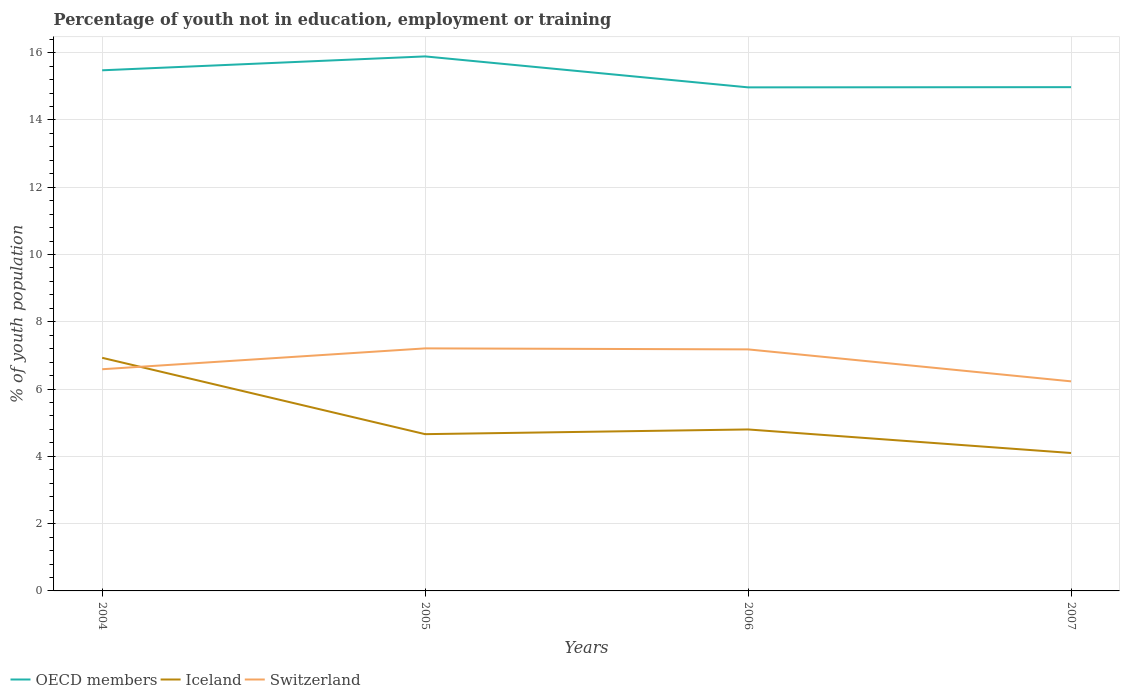How many different coloured lines are there?
Offer a terse response. 3. Does the line corresponding to OECD members intersect with the line corresponding to Iceland?
Ensure brevity in your answer.  No. Is the number of lines equal to the number of legend labels?
Ensure brevity in your answer.  Yes. Across all years, what is the maximum percentage of unemployed youth population in in Iceland?
Provide a succinct answer. 4.1. What is the total percentage of unemployed youth population in in Switzerland in the graph?
Your response must be concise. -0.59. What is the difference between the highest and the second highest percentage of unemployed youth population in in OECD members?
Offer a very short reply. 0.92. What is the difference between the highest and the lowest percentage of unemployed youth population in in Switzerland?
Provide a succinct answer. 2. How many lines are there?
Give a very brief answer. 3. How many years are there in the graph?
Your answer should be compact. 4. Are the values on the major ticks of Y-axis written in scientific E-notation?
Ensure brevity in your answer.  No. Where does the legend appear in the graph?
Ensure brevity in your answer.  Bottom left. What is the title of the graph?
Make the answer very short. Percentage of youth not in education, employment or training. Does "Estonia" appear as one of the legend labels in the graph?
Give a very brief answer. No. What is the label or title of the Y-axis?
Give a very brief answer. % of youth population. What is the % of youth population in OECD members in 2004?
Make the answer very short. 15.48. What is the % of youth population of Iceland in 2004?
Your answer should be compact. 6.93. What is the % of youth population in Switzerland in 2004?
Make the answer very short. 6.59. What is the % of youth population of OECD members in 2005?
Provide a succinct answer. 15.89. What is the % of youth population in Iceland in 2005?
Provide a succinct answer. 4.66. What is the % of youth population in Switzerland in 2005?
Your answer should be very brief. 7.21. What is the % of youth population in OECD members in 2006?
Offer a very short reply. 14.97. What is the % of youth population in Iceland in 2006?
Provide a short and direct response. 4.8. What is the % of youth population in Switzerland in 2006?
Give a very brief answer. 7.18. What is the % of youth population of OECD members in 2007?
Your answer should be compact. 14.98. What is the % of youth population of Iceland in 2007?
Give a very brief answer. 4.1. What is the % of youth population of Switzerland in 2007?
Offer a terse response. 6.23. Across all years, what is the maximum % of youth population of OECD members?
Provide a succinct answer. 15.89. Across all years, what is the maximum % of youth population in Iceland?
Provide a short and direct response. 6.93. Across all years, what is the maximum % of youth population in Switzerland?
Give a very brief answer. 7.21. Across all years, what is the minimum % of youth population of OECD members?
Your answer should be compact. 14.97. Across all years, what is the minimum % of youth population of Iceland?
Ensure brevity in your answer.  4.1. Across all years, what is the minimum % of youth population in Switzerland?
Provide a short and direct response. 6.23. What is the total % of youth population in OECD members in the graph?
Offer a very short reply. 61.31. What is the total % of youth population of Iceland in the graph?
Offer a terse response. 20.49. What is the total % of youth population of Switzerland in the graph?
Offer a terse response. 27.21. What is the difference between the % of youth population in OECD members in 2004 and that in 2005?
Make the answer very short. -0.41. What is the difference between the % of youth population in Iceland in 2004 and that in 2005?
Your response must be concise. 2.27. What is the difference between the % of youth population in Switzerland in 2004 and that in 2005?
Your answer should be compact. -0.62. What is the difference between the % of youth population of OECD members in 2004 and that in 2006?
Make the answer very short. 0.51. What is the difference between the % of youth population in Iceland in 2004 and that in 2006?
Offer a terse response. 2.13. What is the difference between the % of youth population in Switzerland in 2004 and that in 2006?
Provide a short and direct response. -0.59. What is the difference between the % of youth population in OECD members in 2004 and that in 2007?
Provide a succinct answer. 0.5. What is the difference between the % of youth population in Iceland in 2004 and that in 2007?
Your answer should be very brief. 2.83. What is the difference between the % of youth population in Switzerland in 2004 and that in 2007?
Your answer should be compact. 0.36. What is the difference between the % of youth population in OECD members in 2005 and that in 2006?
Provide a succinct answer. 0.92. What is the difference between the % of youth population of Iceland in 2005 and that in 2006?
Make the answer very short. -0.14. What is the difference between the % of youth population in OECD members in 2005 and that in 2007?
Provide a succinct answer. 0.91. What is the difference between the % of youth population of Iceland in 2005 and that in 2007?
Give a very brief answer. 0.56. What is the difference between the % of youth population of OECD members in 2006 and that in 2007?
Your response must be concise. -0.01. What is the difference between the % of youth population in OECD members in 2004 and the % of youth population in Iceland in 2005?
Your answer should be compact. 10.82. What is the difference between the % of youth population of OECD members in 2004 and the % of youth population of Switzerland in 2005?
Offer a very short reply. 8.27. What is the difference between the % of youth population in Iceland in 2004 and the % of youth population in Switzerland in 2005?
Keep it short and to the point. -0.28. What is the difference between the % of youth population of OECD members in 2004 and the % of youth population of Iceland in 2006?
Offer a very short reply. 10.68. What is the difference between the % of youth population of OECD members in 2004 and the % of youth population of Switzerland in 2006?
Provide a succinct answer. 8.3. What is the difference between the % of youth population of OECD members in 2004 and the % of youth population of Iceland in 2007?
Ensure brevity in your answer.  11.38. What is the difference between the % of youth population of OECD members in 2004 and the % of youth population of Switzerland in 2007?
Offer a terse response. 9.25. What is the difference between the % of youth population of OECD members in 2005 and the % of youth population of Iceland in 2006?
Offer a terse response. 11.09. What is the difference between the % of youth population in OECD members in 2005 and the % of youth population in Switzerland in 2006?
Ensure brevity in your answer.  8.71. What is the difference between the % of youth population in Iceland in 2005 and the % of youth population in Switzerland in 2006?
Offer a very short reply. -2.52. What is the difference between the % of youth population in OECD members in 2005 and the % of youth population in Iceland in 2007?
Ensure brevity in your answer.  11.79. What is the difference between the % of youth population in OECD members in 2005 and the % of youth population in Switzerland in 2007?
Your response must be concise. 9.66. What is the difference between the % of youth population of Iceland in 2005 and the % of youth population of Switzerland in 2007?
Your answer should be compact. -1.57. What is the difference between the % of youth population in OECD members in 2006 and the % of youth population in Iceland in 2007?
Offer a terse response. 10.87. What is the difference between the % of youth population of OECD members in 2006 and the % of youth population of Switzerland in 2007?
Offer a terse response. 8.74. What is the difference between the % of youth population in Iceland in 2006 and the % of youth population in Switzerland in 2007?
Your answer should be very brief. -1.43. What is the average % of youth population of OECD members per year?
Make the answer very short. 15.33. What is the average % of youth population of Iceland per year?
Keep it short and to the point. 5.12. What is the average % of youth population of Switzerland per year?
Keep it short and to the point. 6.8. In the year 2004, what is the difference between the % of youth population in OECD members and % of youth population in Iceland?
Give a very brief answer. 8.55. In the year 2004, what is the difference between the % of youth population of OECD members and % of youth population of Switzerland?
Your response must be concise. 8.89. In the year 2004, what is the difference between the % of youth population in Iceland and % of youth population in Switzerland?
Keep it short and to the point. 0.34. In the year 2005, what is the difference between the % of youth population of OECD members and % of youth population of Iceland?
Provide a short and direct response. 11.23. In the year 2005, what is the difference between the % of youth population in OECD members and % of youth population in Switzerland?
Your answer should be compact. 8.68. In the year 2005, what is the difference between the % of youth population of Iceland and % of youth population of Switzerland?
Your answer should be compact. -2.55. In the year 2006, what is the difference between the % of youth population of OECD members and % of youth population of Iceland?
Make the answer very short. 10.17. In the year 2006, what is the difference between the % of youth population in OECD members and % of youth population in Switzerland?
Keep it short and to the point. 7.79. In the year 2006, what is the difference between the % of youth population in Iceland and % of youth population in Switzerland?
Make the answer very short. -2.38. In the year 2007, what is the difference between the % of youth population of OECD members and % of youth population of Iceland?
Make the answer very short. 10.88. In the year 2007, what is the difference between the % of youth population in OECD members and % of youth population in Switzerland?
Your answer should be very brief. 8.75. In the year 2007, what is the difference between the % of youth population in Iceland and % of youth population in Switzerland?
Make the answer very short. -2.13. What is the ratio of the % of youth population in OECD members in 2004 to that in 2005?
Provide a short and direct response. 0.97. What is the ratio of the % of youth population in Iceland in 2004 to that in 2005?
Your answer should be very brief. 1.49. What is the ratio of the % of youth population of Switzerland in 2004 to that in 2005?
Provide a succinct answer. 0.91. What is the ratio of the % of youth population in OECD members in 2004 to that in 2006?
Provide a short and direct response. 1.03. What is the ratio of the % of youth population in Iceland in 2004 to that in 2006?
Offer a terse response. 1.44. What is the ratio of the % of youth population of Switzerland in 2004 to that in 2006?
Your answer should be very brief. 0.92. What is the ratio of the % of youth population of OECD members in 2004 to that in 2007?
Keep it short and to the point. 1.03. What is the ratio of the % of youth population of Iceland in 2004 to that in 2007?
Give a very brief answer. 1.69. What is the ratio of the % of youth population of Switzerland in 2004 to that in 2007?
Your answer should be very brief. 1.06. What is the ratio of the % of youth population in OECD members in 2005 to that in 2006?
Make the answer very short. 1.06. What is the ratio of the % of youth population in Iceland in 2005 to that in 2006?
Your answer should be very brief. 0.97. What is the ratio of the % of youth population in Switzerland in 2005 to that in 2006?
Keep it short and to the point. 1. What is the ratio of the % of youth population of OECD members in 2005 to that in 2007?
Offer a terse response. 1.06. What is the ratio of the % of youth population of Iceland in 2005 to that in 2007?
Ensure brevity in your answer.  1.14. What is the ratio of the % of youth population in Switzerland in 2005 to that in 2007?
Your answer should be very brief. 1.16. What is the ratio of the % of youth population in OECD members in 2006 to that in 2007?
Keep it short and to the point. 1. What is the ratio of the % of youth population in Iceland in 2006 to that in 2007?
Ensure brevity in your answer.  1.17. What is the ratio of the % of youth population in Switzerland in 2006 to that in 2007?
Provide a short and direct response. 1.15. What is the difference between the highest and the second highest % of youth population in OECD members?
Ensure brevity in your answer.  0.41. What is the difference between the highest and the second highest % of youth population of Iceland?
Ensure brevity in your answer.  2.13. What is the difference between the highest and the second highest % of youth population of Switzerland?
Offer a terse response. 0.03. What is the difference between the highest and the lowest % of youth population in OECD members?
Keep it short and to the point. 0.92. What is the difference between the highest and the lowest % of youth population in Iceland?
Your answer should be very brief. 2.83. 